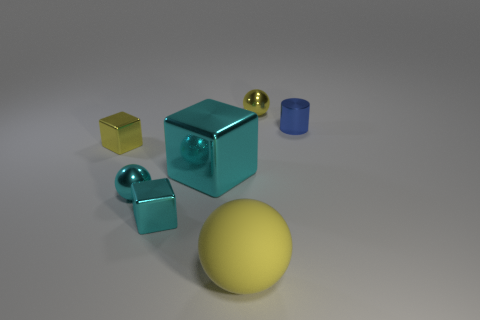Are there any other things that are the same material as the big sphere?
Your answer should be very brief. No. Is there a small shiny thing of the same shape as the large shiny object?
Your answer should be compact. Yes. There is a thing right of the tiny yellow object that is behind the tiny metal cylinder; what is its shape?
Keep it short and to the point. Cylinder. What color is the thing behind the cylinder?
Your answer should be compact. Yellow. What is the size of the blue cylinder that is made of the same material as the big cyan object?
Your answer should be compact. Small. What is the size of the other cyan thing that is the same shape as the large cyan metallic thing?
Your response must be concise. Small. Are there any tiny yellow metal cylinders?
Offer a very short reply. No. How many things are either big metal objects in front of the tiny yellow metallic cube or tiny yellow blocks?
Offer a terse response. 2. There is a small metallic sphere behind the small yellow thing in front of the blue cylinder; what color is it?
Your answer should be compact. Yellow. There is a small yellow metal sphere; how many blue things are behind it?
Give a very brief answer. 0. 